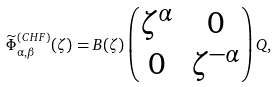<formula> <loc_0><loc_0><loc_500><loc_500>\widetilde { \Phi } _ { \alpha , \beta } ^ { ( C H F ) } ( \zeta ) = B ( \zeta ) \begin{pmatrix} \zeta ^ { \alpha } & 0 \\ 0 & \zeta ^ { - \alpha } \end{pmatrix} Q ,</formula> 